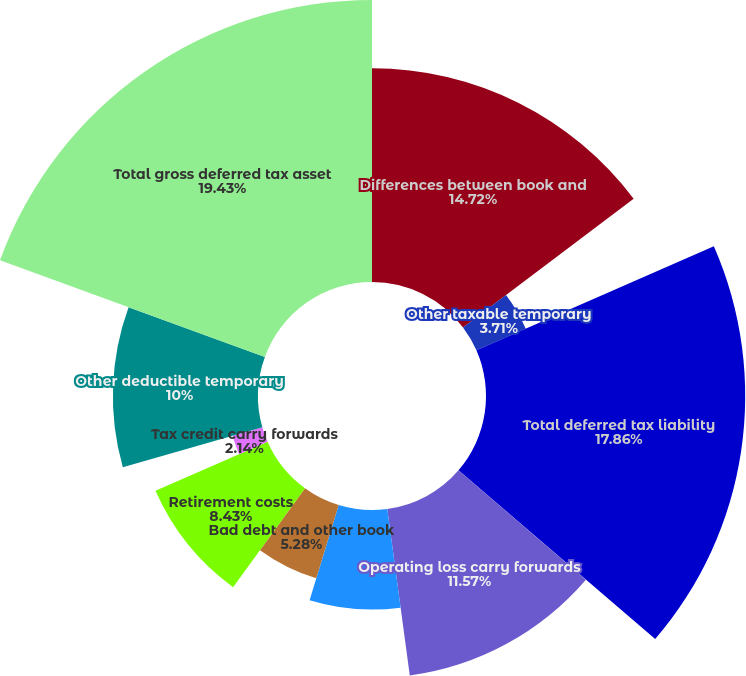Convert chart. <chart><loc_0><loc_0><loc_500><loc_500><pie_chart><fcel>Differences between book and<fcel>Other taxable temporary<fcel>Total deferred tax liability<fcel>Operating loss carry forwards<fcel>Capital loss carry forwards<fcel>Bad debt and other book<fcel>Retirement costs<fcel>Tax credit carry forwards<fcel>Other deductible temporary<fcel>Total gross deferred tax asset<nl><fcel>14.72%<fcel>3.71%<fcel>17.86%<fcel>11.57%<fcel>6.86%<fcel>5.28%<fcel>8.43%<fcel>2.14%<fcel>10.0%<fcel>19.43%<nl></chart> 